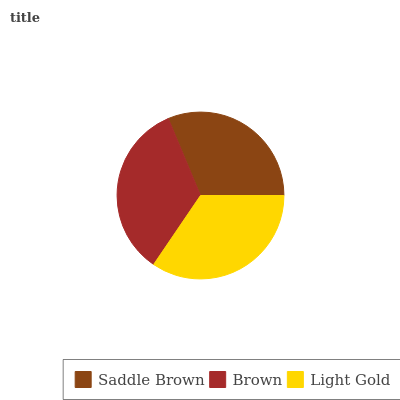Is Saddle Brown the minimum?
Answer yes or no. Yes. Is Light Gold the maximum?
Answer yes or no. Yes. Is Brown the minimum?
Answer yes or no. No. Is Brown the maximum?
Answer yes or no. No. Is Brown greater than Saddle Brown?
Answer yes or no. Yes. Is Saddle Brown less than Brown?
Answer yes or no. Yes. Is Saddle Brown greater than Brown?
Answer yes or no. No. Is Brown less than Saddle Brown?
Answer yes or no. No. Is Brown the high median?
Answer yes or no. Yes. Is Brown the low median?
Answer yes or no. Yes. Is Saddle Brown the high median?
Answer yes or no. No. Is Saddle Brown the low median?
Answer yes or no. No. 